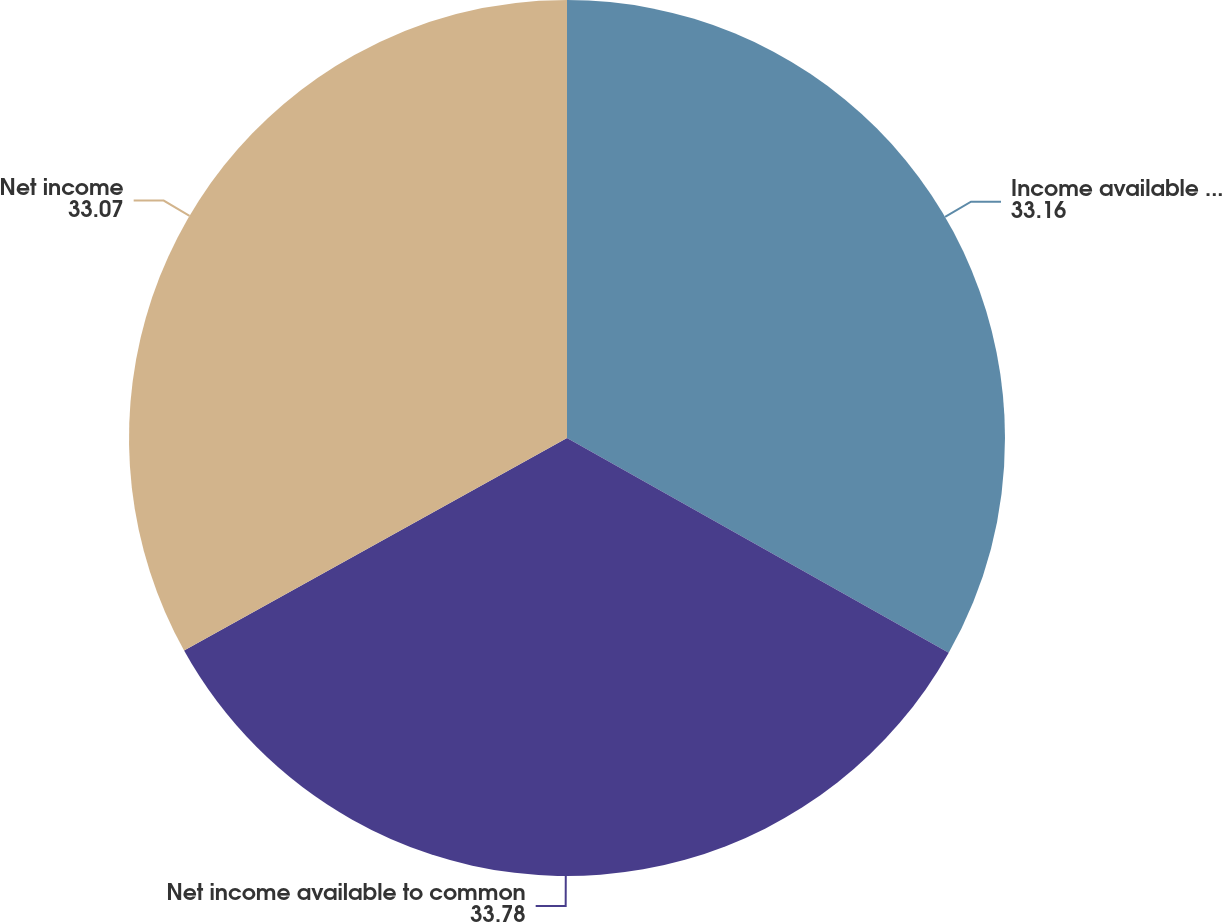Convert chart. <chart><loc_0><loc_0><loc_500><loc_500><pie_chart><fcel>Income available to common<fcel>Net income available to common<fcel>Net income<nl><fcel>33.16%<fcel>33.78%<fcel>33.07%<nl></chart> 